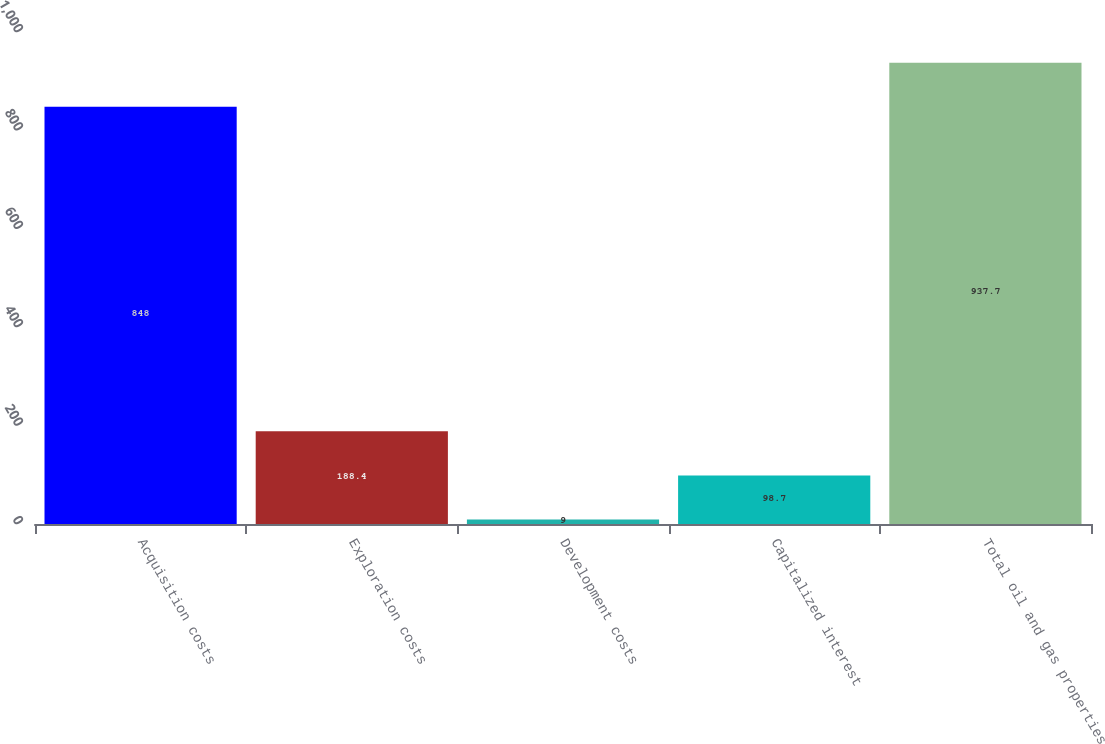Convert chart to OTSL. <chart><loc_0><loc_0><loc_500><loc_500><bar_chart><fcel>Acquisition costs<fcel>Exploration costs<fcel>Development costs<fcel>Capitalized interest<fcel>Total oil and gas properties<nl><fcel>848<fcel>188.4<fcel>9<fcel>98.7<fcel>937.7<nl></chart> 